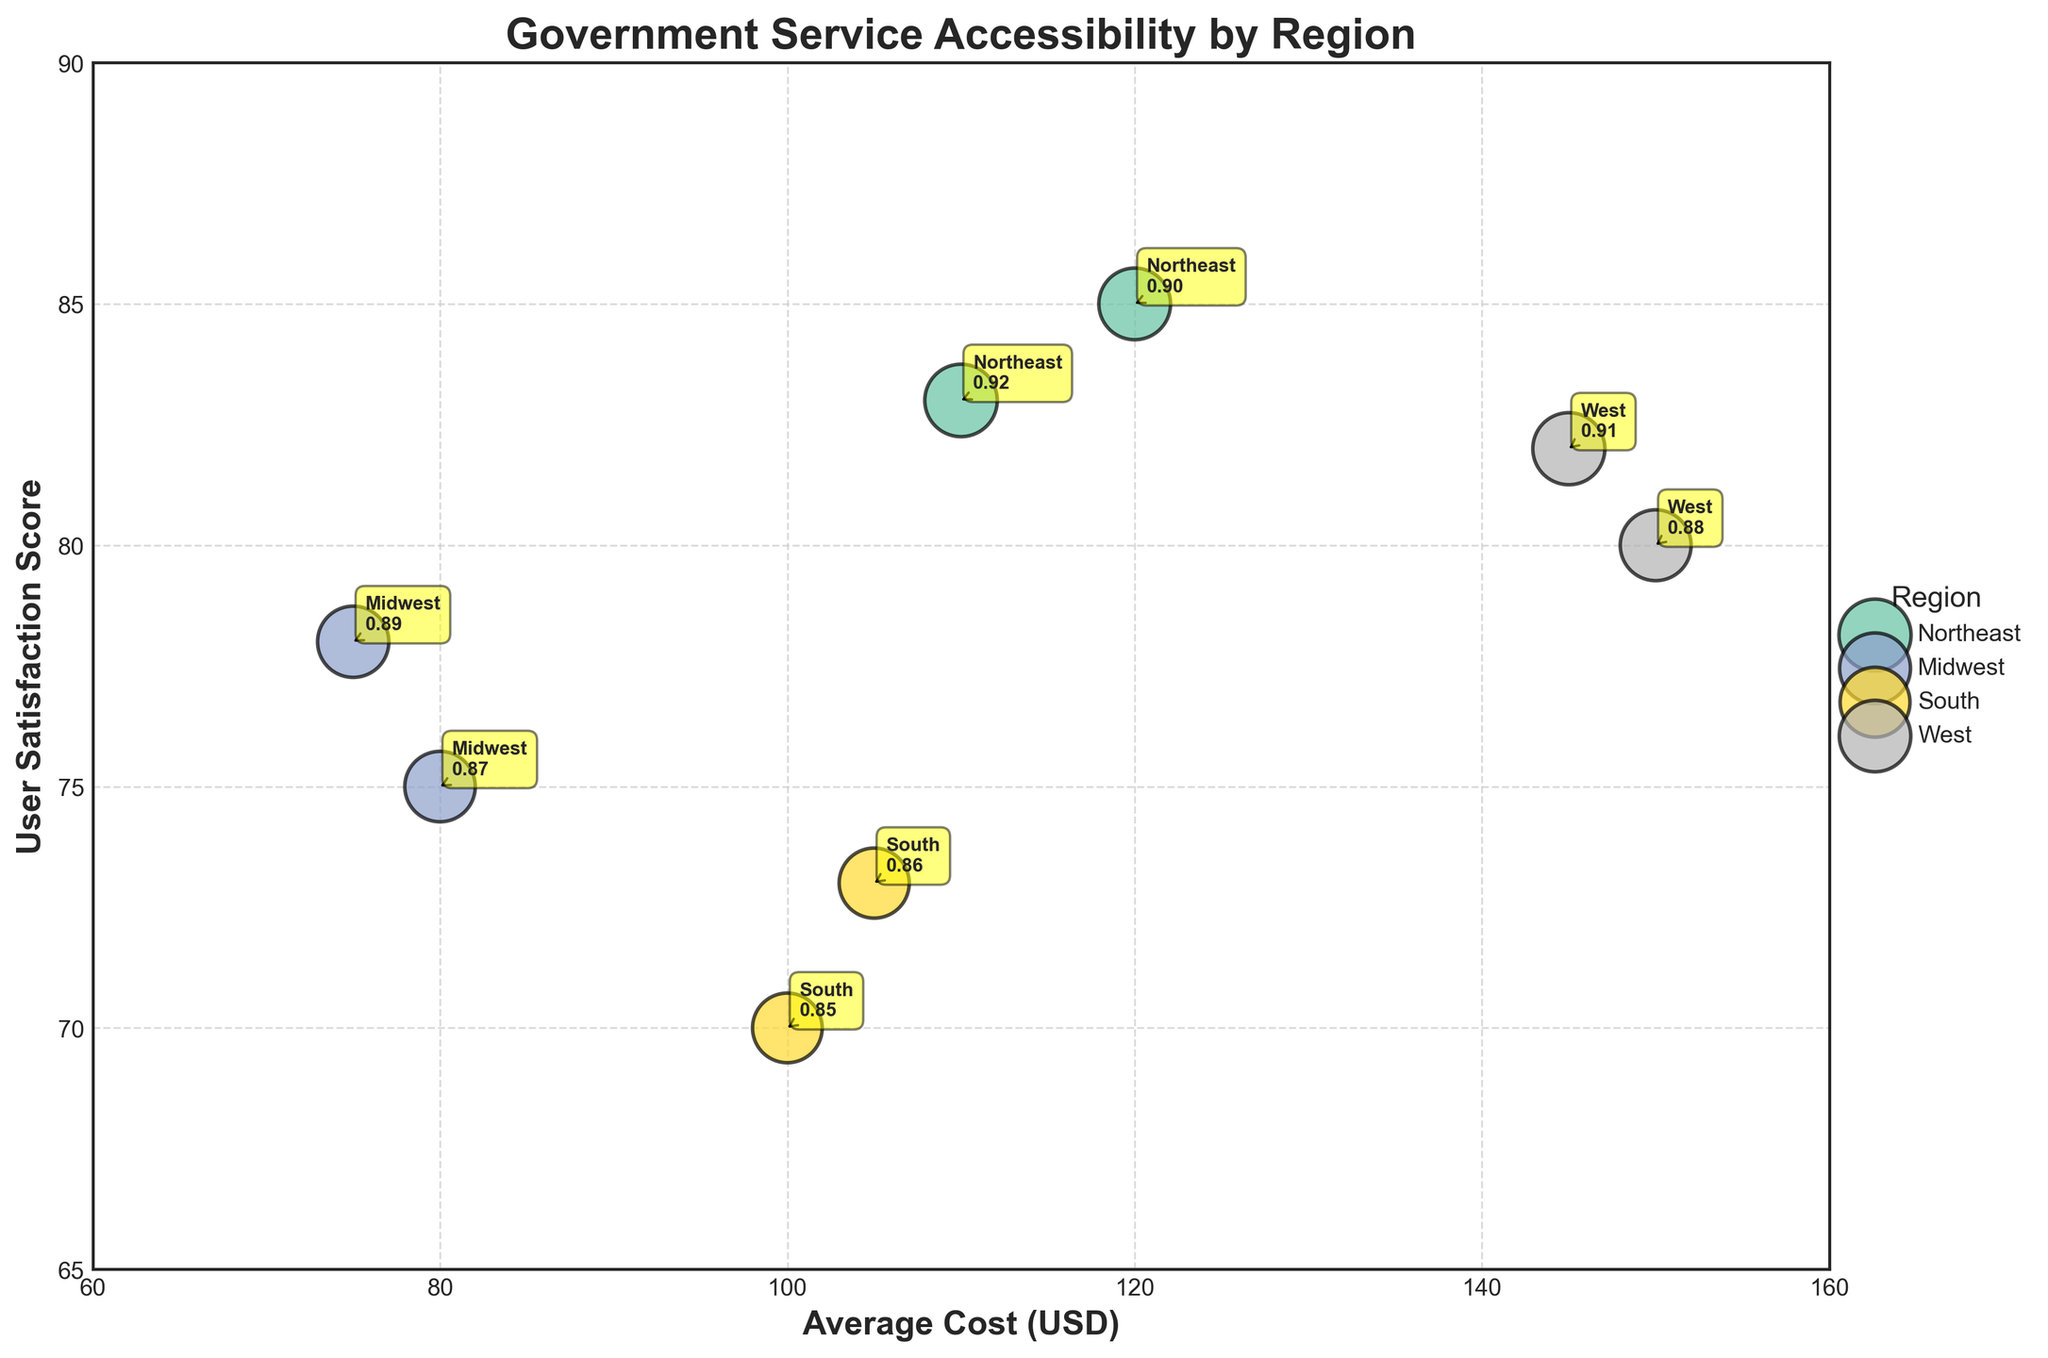What's the title of the figure? The title is prominently displayed at the top of the figure in bold font.
Answer: Government Service Accessibility by Region What are the x and y-axis labels? The x-axis label is shown below the x-axis, and the y-axis label is displayed beside the y-axis.
Answer: Average Cost (USD) and User Satisfaction Score Which region has the lowest average cost? Locate the region that appears furthest to the left on the x-axis (since the x-axis represents average costs).
Answer: Midwest ($75 and $80) Which region has the highest user satisfaction score? Identify the region with the highest value on the y-axis, as the y-axis represents user satisfaction score.
Answer: Northeast (85) Compare the average costs and user satisfaction scores between the Northeast and South regions. For the Northeast, the average costs are $120 and $110 with satisfaction scores of 85 and 83. For the South, the average costs are $100 and $105 with satisfaction scores of 70 and 73. Calculate differences.
Answer: Northeast is more costly but has higher satisfaction Which region has the highest Service Accessibility Index? The Service Accessibility Index is represented by the size of the bubbles; the largest bubble corresponds to the highest index.
Answer: Northeast (0.92) What is the range of the Service Accessibility Index in the West region? Identify the bubbles corresponding to the West region and note the sizes. The accessibility index sizes are 0.88 and 0.91.
Answer: 0.88 to 0.91 How many regions are plotted in the figure? Count the number of distinct colors or labels in the legend representing different regions.
Answer: Four regions Which region has the smallest bubble size? What is its Accessibility Index? Identify the smallest bubble in the plot and refer to the region name and size value labeled on it.
Answer: Midwest (0.87) Between the Midwest and South, which region has higher user satisfaction scores? Compare the y-axis values for bubbles labeled Midwest and South.
Answer: Midwest (75, 78 compared to South's 70, 73) What is the average Service Accessibility Index of the regions? Calculate the mean of all Service Accessibility Index values: (0.90+0.87+0.85+0.88+0.92+0.89+0.86+0.91)/8.
Answer: 0.88 